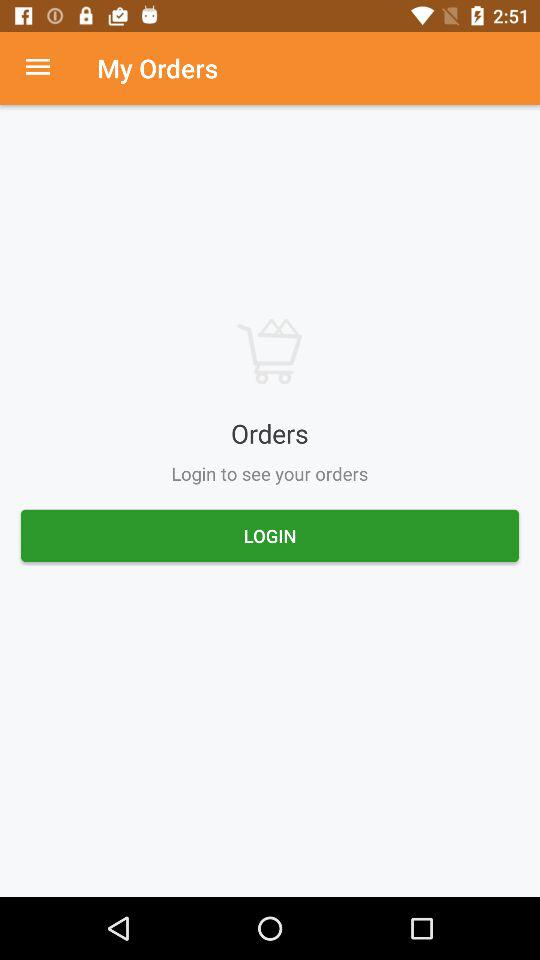How many more shopping carts than my orders does the screen have?
Answer the question using a single word or phrase. 1 